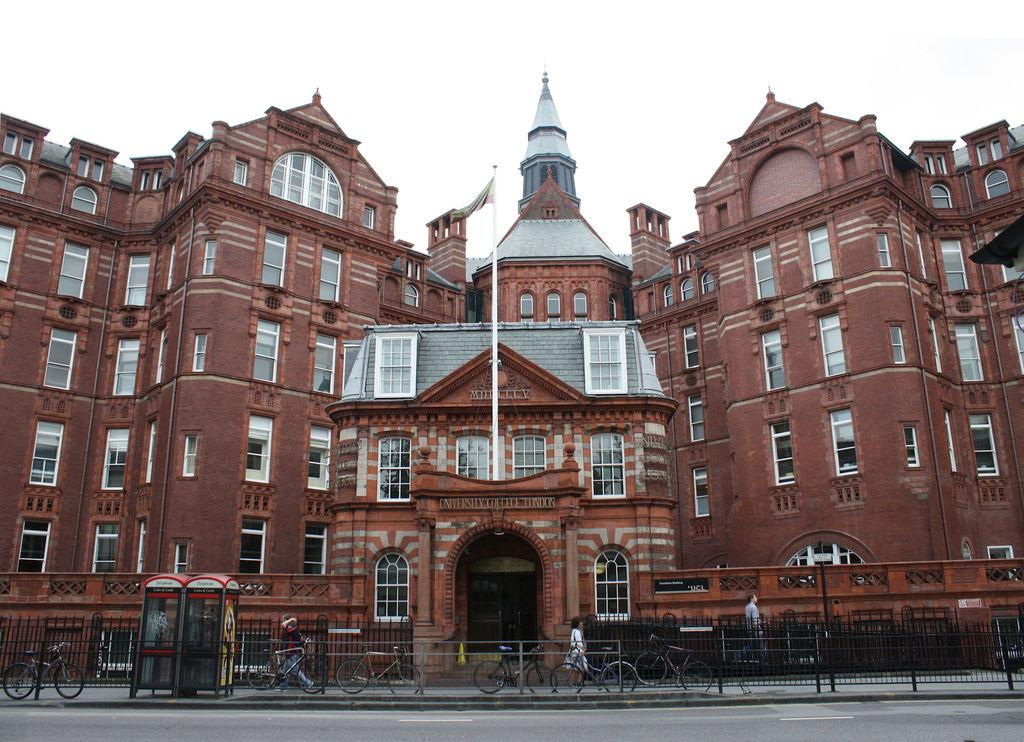What is the color of the building in the image? The building in the image is brown-colored. What can be seen at the top of the image? The sky is visible at the top of the image. What mode of transportation is present in the image? There are cycles in the image. Are there any people in the image? Yes, there are persons in the image. What religious symbol can be seen on the building in the image? There is no religious symbol visible on the building in the image. What team is represented by the persons in the image? There is no indication of a team in the image; it simply shows persons and cycles. 